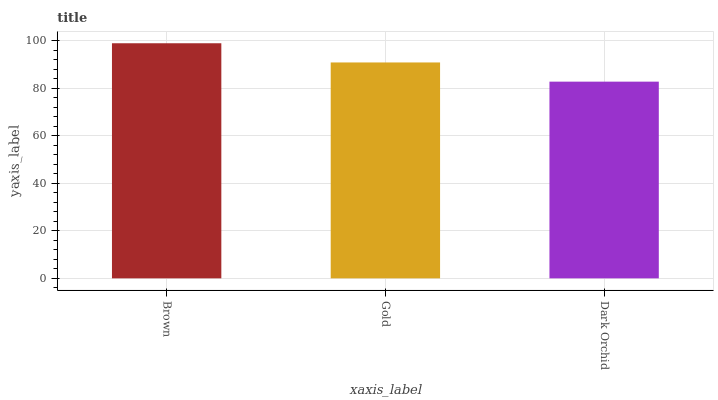Is Dark Orchid the minimum?
Answer yes or no. Yes. Is Brown the maximum?
Answer yes or no. Yes. Is Gold the minimum?
Answer yes or no. No. Is Gold the maximum?
Answer yes or no. No. Is Brown greater than Gold?
Answer yes or no. Yes. Is Gold less than Brown?
Answer yes or no. Yes. Is Gold greater than Brown?
Answer yes or no. No. Is Brown less than Gold?
Answer yes or no. No. Is Gold the high median?
Answer yes or no. Yes. Is Gold the low median?
Answer yes or no. Yes. Is Brown the high median?
Answer yes or no. No. Is Brown the low median?
Answer yes or no. No. 